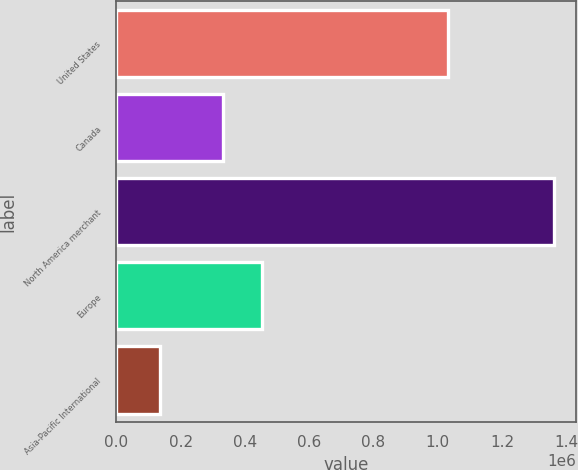<chart> <loc_0><loc_0><loc_500><loc_500><bar_chart><fcel>United States<fcel>Canada<fcel>North America merchant<fcel>Europe<fcel>Asia-Pacific International<nl><fcel>1.032e+06<fcel>330872<fcel>1.36287e+06<fcel>453422<fcel>137366<nl></chart> 